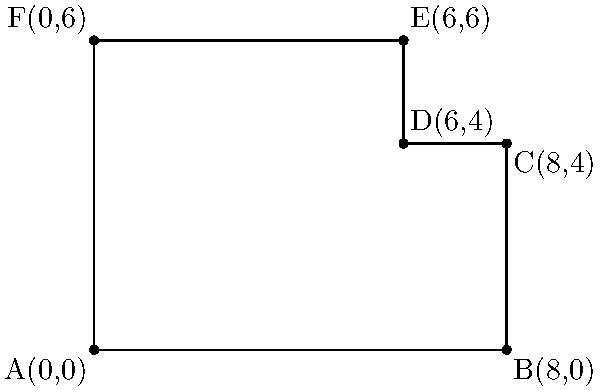As the HR manager of a growing company, you need to determine the area of the new irregularly shaped office space. The space is represented by the coordinates A(0,0), B(8,0), C(8,4), D(6,4), E(6,6), and F(0,6). Calculate the total area of this office space using coordinate geometry. To find the area of this irregular shape, we can divide it into two rectangles:

1. Rectangle ABCF:
   Width = $8 - 0 = 8$ units
   Height = $4 - 0 = 4$ units
   Area of ABCF = $8 \times 4 = 32$ square units

2. Rectangle CDEF:
   Width = $6 - 0 = 6$ units
   Height = $6 - 4 = 2$ units
   Area of CDEF = $6 \times 2 = 12$ square units

3. Total area:
   $$\text{Total Area} = \text{Area of ABCF} + \text{Area of CDEF}$$
   $$\text{Total Area} = 32 + 12 = 44\text{ square units}$$

Therefore, the total area of the office space is 44 square units.
Answer: 44 square units 